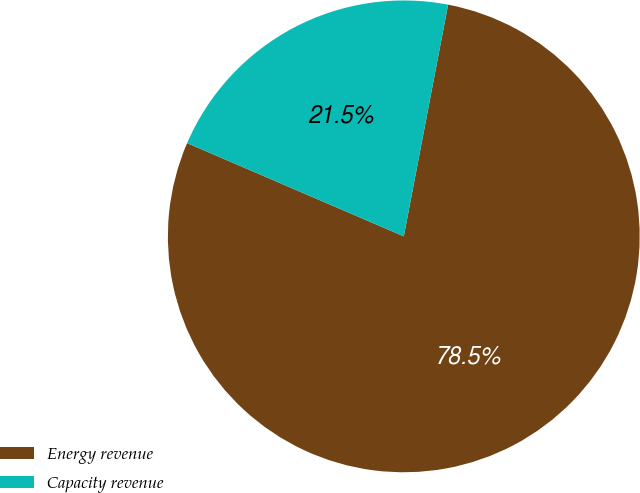<chart> <loc_0><loc_0><loc_500><loc_500><pie_chart><fcel>Energy revenue<fcel>Capacity revenue<nl><fcel>78.46%<fcel>21.54%<nl></chart> 